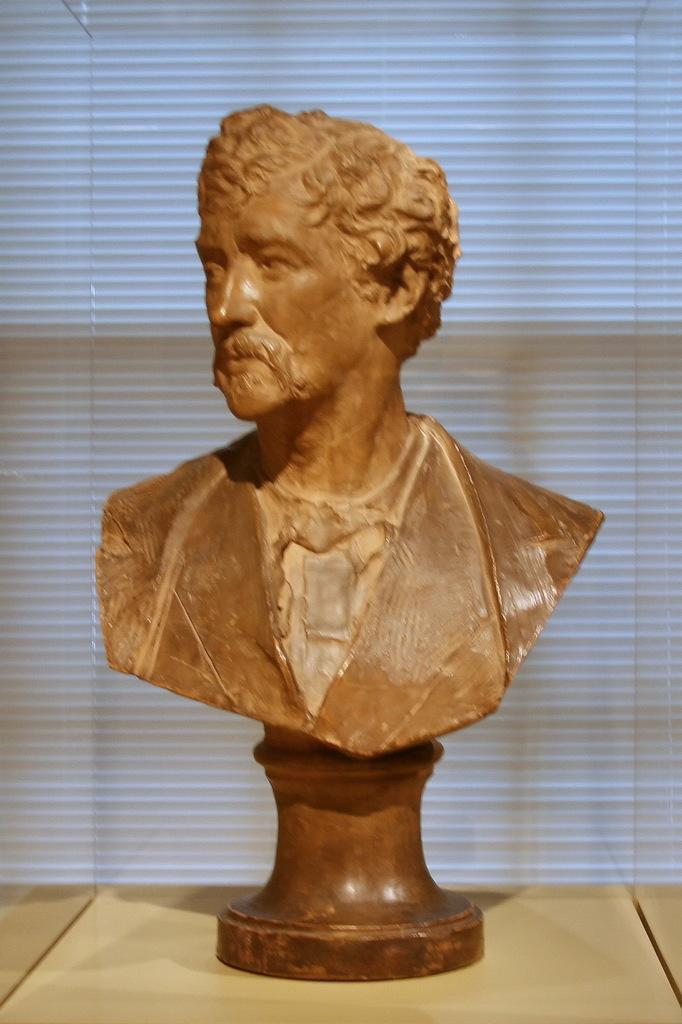In one or two sentences, can you explain what this image depicts? Here we can see a statue of a man on a stand on a platform which is placed in a glass box. In the background we can see an object. 